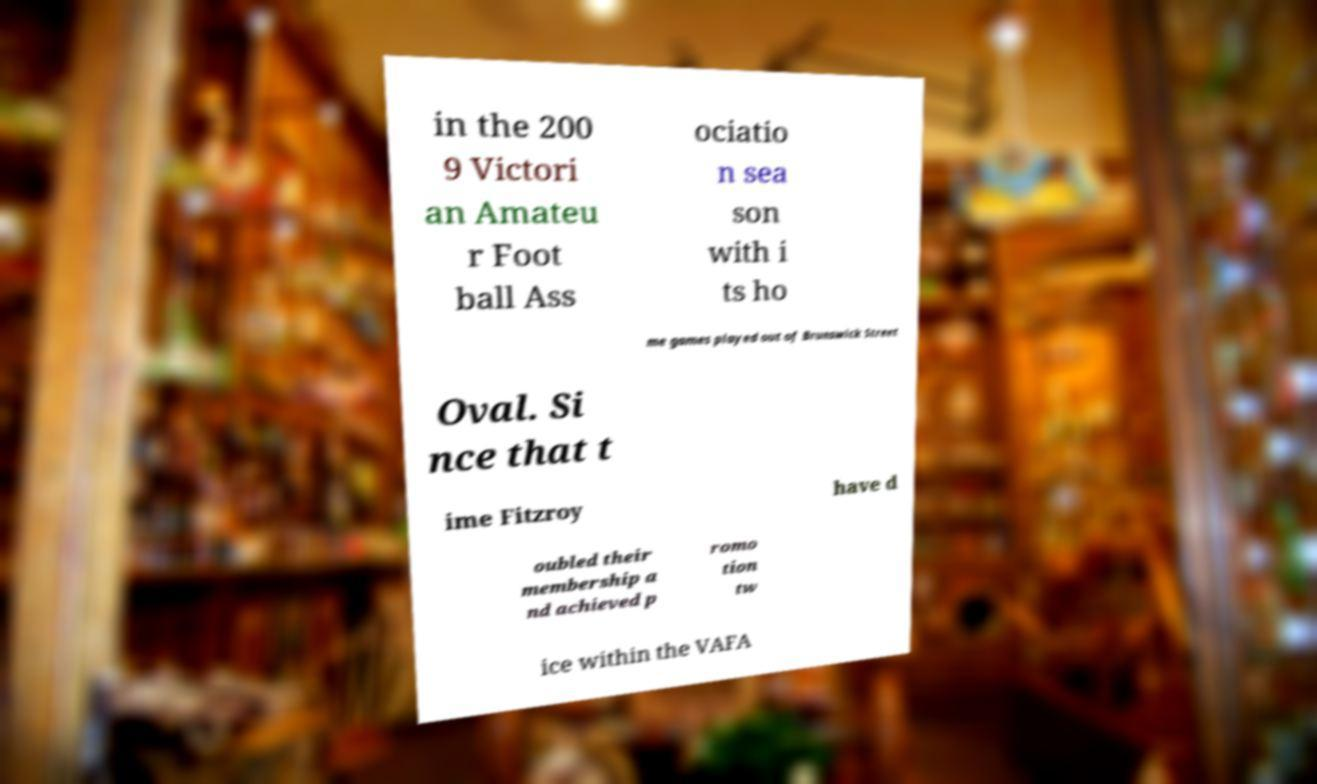There's text embedded in this image that I need extracted. Can you transcribe it verbatim? in the 200 9 Victori an Amateu r Foot ball Ass ociatio n sea son with i ts ho me games played out of Brunswick Street Oval. Si nce that t ime Fitzroy have d oubled their membership a nd achieved p romo tion tw ice within the VAFA 